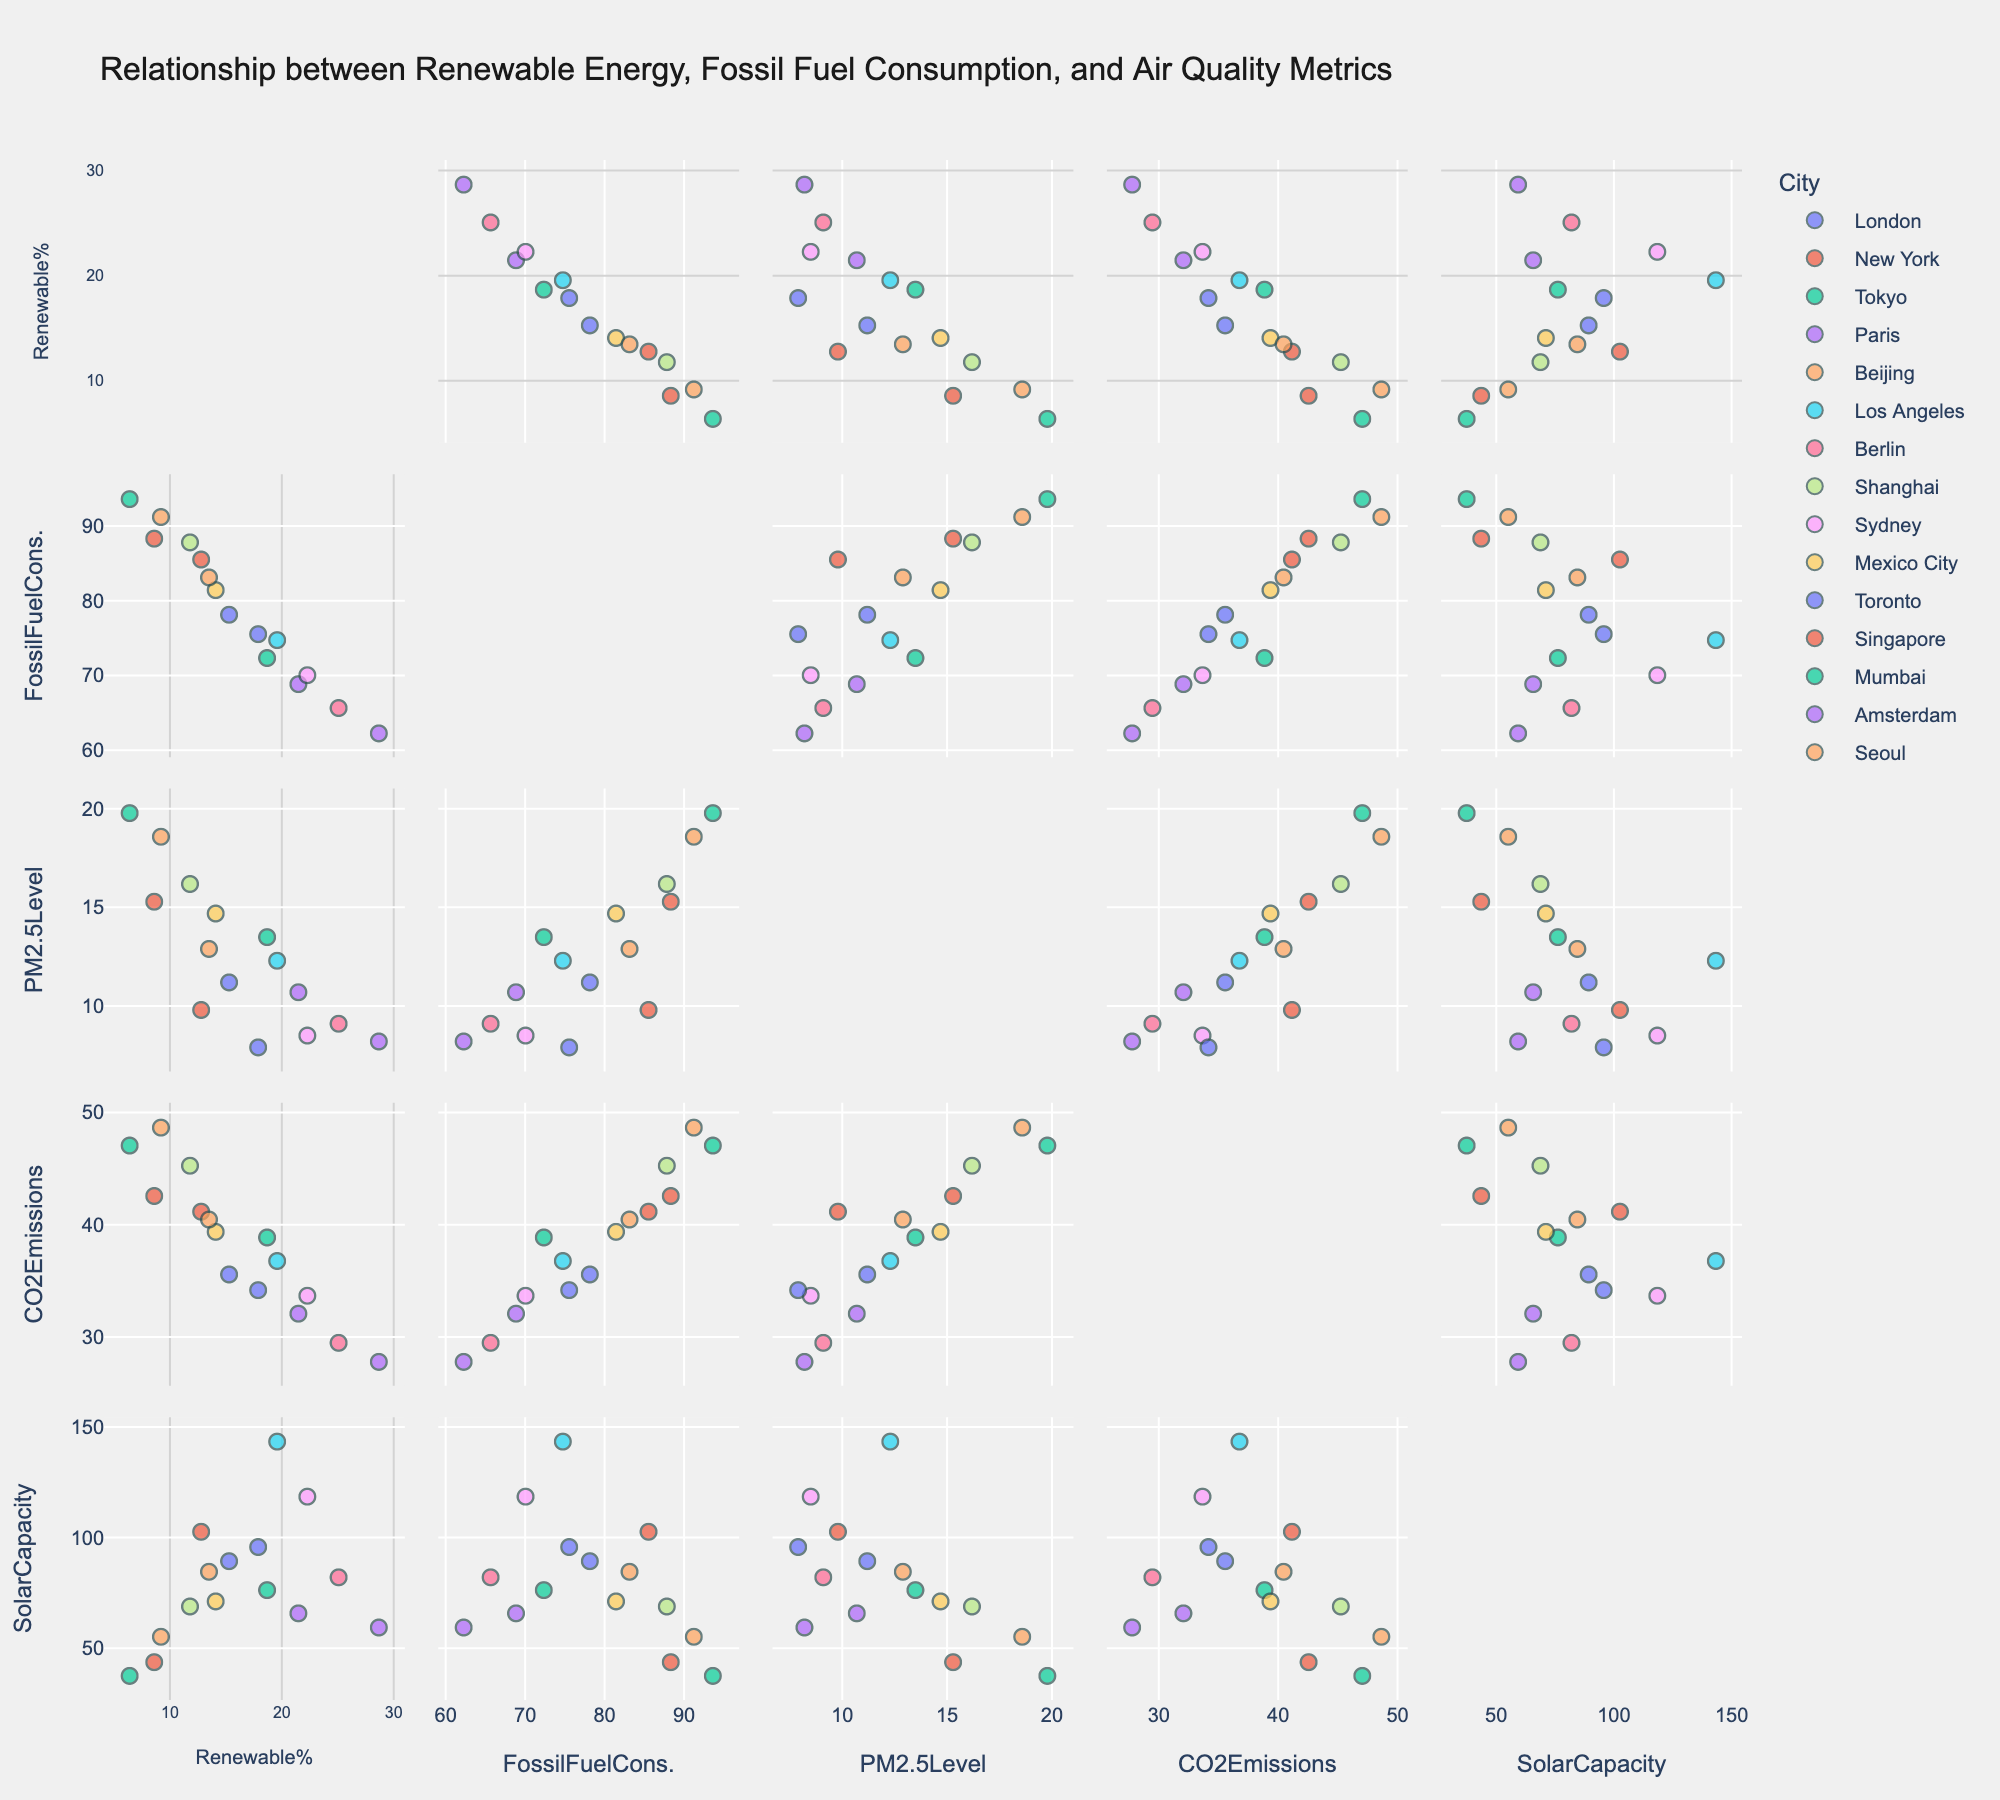What is the title of the figure? The title is located at the top of the figure.
Answer: Relationship between Renewable Energy, Fossil Fuel Consumption, and Air Quality Metrics How many urban areas are represented in the scatterplot matrix? Each unique color corresponds to a different urban area, and there are 15 unique colors in the legend.
Answer: 15 Which city has the highest percentage of renewable energy adoption? Look at the 'RenewablePercentage' column and identify the city with the highest value.
Answer: Amsterdam What is the relationship between RenewablePercentage and PM2.5Level for cities with over 20% renewable energy adoption? Filter cities with over 20% renewable energy adoption (e.g., Paris, Amsterdam, Sydney, Berlin) and compare their PM2.5 levels.
Answer: Generally lower PM2.5 levels Which urban area combines high FossilFuelConsumption and high PM2.5Level? Look for the data points in the upper-right quadrant of the scatterplot between 'FossilFuelConsumption' and 'PM2.5Level'.
Answer: Beijing Is there a visible correlation between CO2Emissions and SolarCapacity? Look at the scatterplot between 'CO2Emissions' and 'SolarCapacity' to see if a pattern is evident.
Answer: No strong visible correlation What is the range of PM2.5 levels across all cities? Identify the smallest and largest PM2.5 levels among all the urban areas.
Answer: 7.9 - 19.8 How does Los Angeles compare to New York in terms of SolarCapacity? Locate the data points for Los Angeles and New York, and compare their SolarCapacity values.
Answer: Los Angeles has a higher SolarCapacity Which city has the lowest CO2 emissions? Check the 'CO2Emissions' column and identify the city with the lowest value.
Answer: Amsterdam Is there an inverse relationship between RenewablePercentage and FossilFuelConsumption? Observe the scatterplot between 'RenewablePercentage' and 'FossilFuelConsumption' to determine the trend direction.
Answer: Yes, generally inverse 